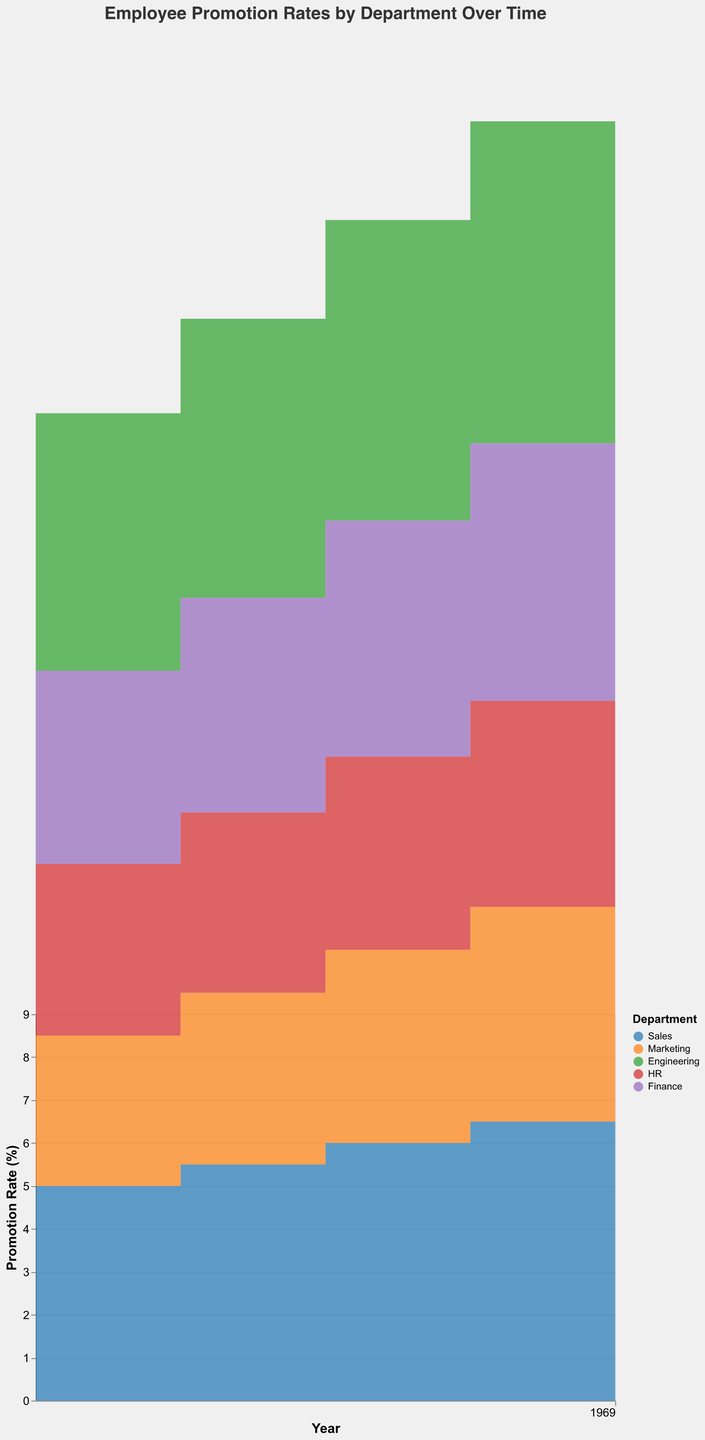What's the title of the figure? The title is displayed at the top of the figure. It helps understand what the plot is about.
Answer: Employee Promotion Rates by Department Over Time Which department had the highest promotion rate in 2022? Find the highest value on the y-axis for 2022 and check the corresponding department.
Answer: Engineering How did the promotion rate in the HR department change from 2018 to 2022? Identify the promotion rate for HR in 2018 and compare it with the promotion rate in 2022. The rate increases from 4.0% in 2018 to 5.0% in 2022.
Answer: Increased by 1% Which department had a steady (consistent) increase in promotion rate over the years? Observe the trends for each department from 2018 to 2022. Sales and Engineering show consistent year-over-year increases.
Answer: Sales and Engineering In which year did the Finance department see the steepest increase in promotion rate? Look at the step patterns for Finance. The largest jump is between 2020 and 2021, from 5.5% to 6.0%.
Answer: 2020 to 2021 What is the promotion rate for the Marketing department in 2019? Locate 2019 for the Marketing department and read the value where the line intersects the y-axis.
Answer: 4.0% Which two departments had the closest promotion rates in 2021? Compare the 2021 values for all departments. Marketing and HR had promotion rates of 5.0% and 4.8%, respectively.
Answer: Marketing and HR What was the promotion rate increase for the Sales department from 2018 to 2020? Find the promotion rate for Sales in both years and calculate the difference: 6.0% (2020) - 5.0% (2018).
Answer: 1.0% What's the difference between the highest and lowest promotion rates in 2022? Identify the highest (Engineering: 8.0%) and lowest (HR: 5.0%) promotion rates in 2022. Difference is 8.0% - 5.0%.
Answer: 3.0% Does any department show a decrease in promotion rate in any year? Check each department's trend for any year where the promotion rate goes down.
Answer: No 